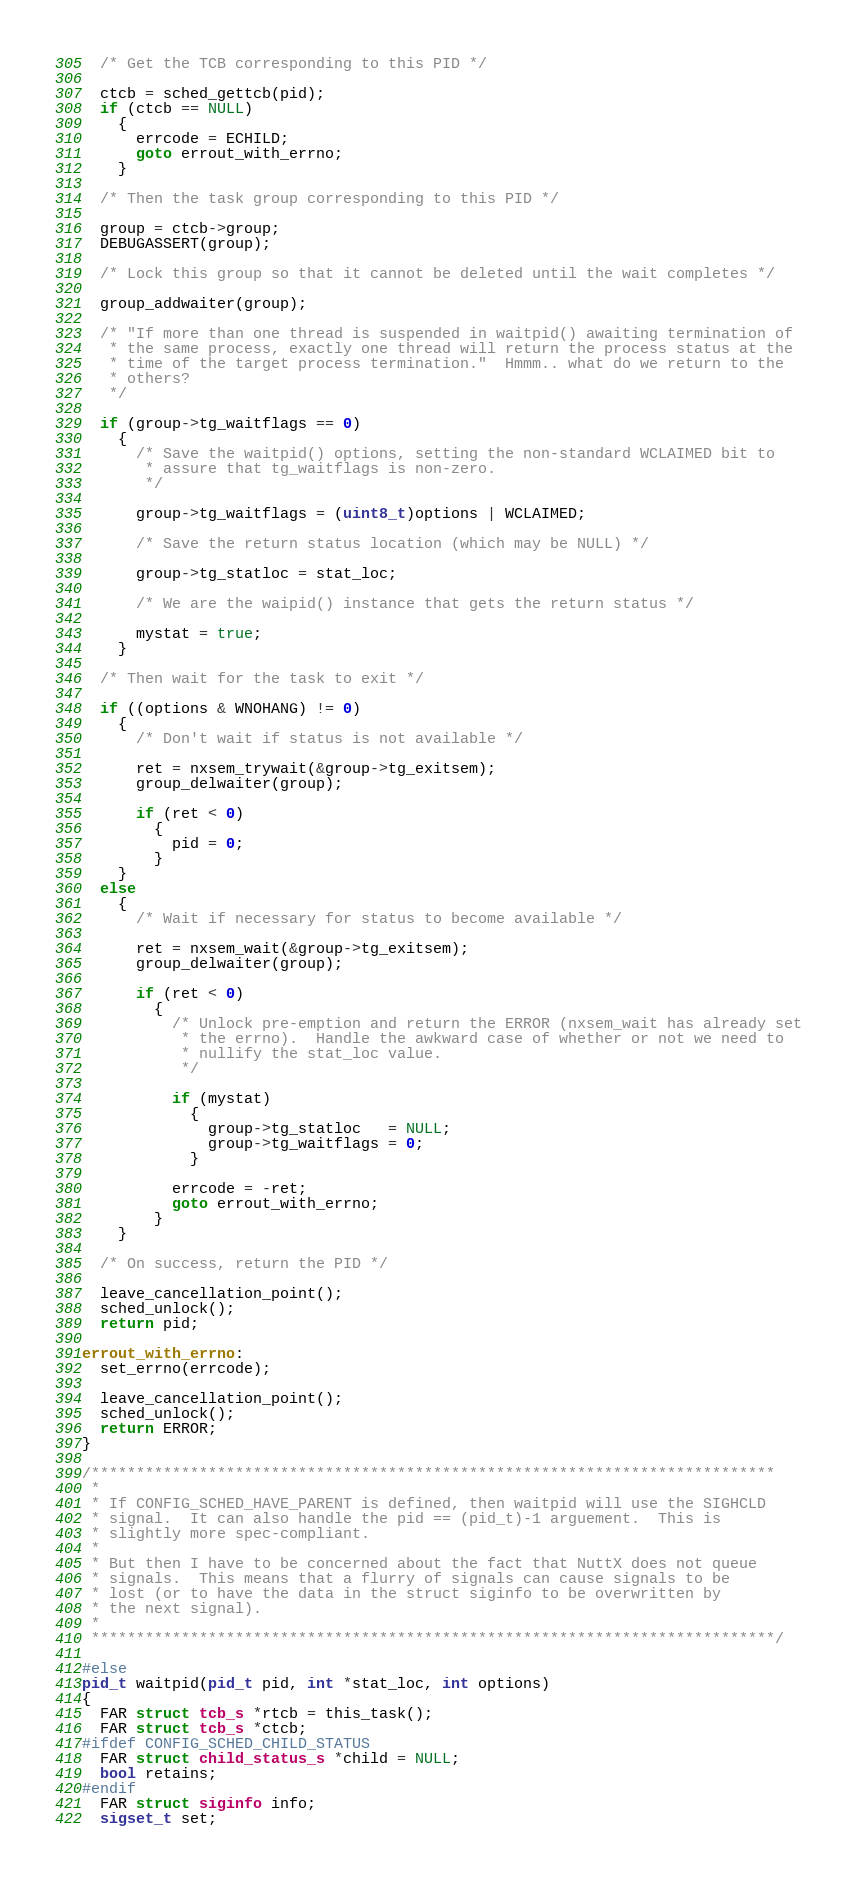Convert code to text. <code><loc_0><loc_0><loc_500><loc_500><_C_>
  /* Get the TCB corresponding to this PID */

  ctcb = sched_gettcb(pid);
  if (ctcb == NULL)
    {
      errcode = ECHILD;
      goto errout_with_errno;
    }

  /* Then the task group corresponding to this PID */

  group = ctcb->group;
  DEBUGASSERT(group);

  /* Lock this group so that it cannot be deleted until the wait completes */

  group_addwaiter(group);

  /* "If more than one thread is suspended in waitpid() awaiting termination of
   * the same process, exactly one thread will return the process status at the
   * time of the target process termination."  Hmmm.. what do we return to the
   * others?
   */

  if (group->tg_waitflags == 0)
    {
      /* Save the waitpid() options, setting the non-standard WCLAIMED bit to
       * assure that tg_waitflags is non-zero.
       */

      group->tg_waitflags = (uint8_t)options | WCLAIMED;

      /* Save the return status location (which may be NULL) */

      group->tg_statloc = stat_loc;

      /* We are the waipid() instance that gets the return status */

      mystat = true;
    }

  /* Then wait for the task to exit */

  if ((options & WNOHANG) != 0)
    {
      /* Don't wait if status is not available */

      ret = nxsem_trywait(&group->tg_exitsem);
      group_delwaiter(group);

      if (ret < 0)
        {
          pid = 0;
        }
    }
  else
    {
      /* Wait if necessary for status to become available */

      ret = nxsem_wait(&group->tg_exitsem);
      group_delwaiter(group);

      if (ret < 0)
        {
          /* Unlock pre-emption and return the ERROR (nxsem_wait has already set
           * the errno).  Handle the awkward case of whether or not we need to
           * nullify the stat_loc value.
           */

          if (mystat)
            {
              group->tg_statloc   = NULL;
              group->tg_waitflags = 0;
            }

          errcode = -ret;
          goto errout_with_errno;
        }
    }

  /* On success, return the PID */

  leave_cancellation_point();
  sched_unlock();
  return pid;

errout_with_errno:
  set_errno(errcode);

  leave_cancellation_point();
  sched_unlock();
  return ERROR;
}

/****************************************************************************
 *
 * If CONFIG_SCHED_HAVE_PARENT is defined, then waitpid will use the SIGHCLD
 * signal.  It can also handle the pid == (pid_t)-1 arguement.  This is
 * slightly more spec-compliant.
 *
 * But then I have to be concerned about the fact that NuttX does not queue
 * signals.  This means that a flurry of signals can cause signals to be
 * lost (or to have the data in the struct siginfo to be overwritten by
 * the next signal).
 *
 ****************************************************************************/

#else
pid_t waitpid(pid_t pid, int *stat_loc, int options)
{
  FAR struct tcb_s *rtcb = this_task();
  FAR struct tcb_s *ctcb;
#ifdef CONFIG_SCHED_CHILD_STATUS
  FAR struct child_status_s *child = NULL;
  bool retains;
#endif
  FAR struct siginfo info;
  sigset_t set;</code> 